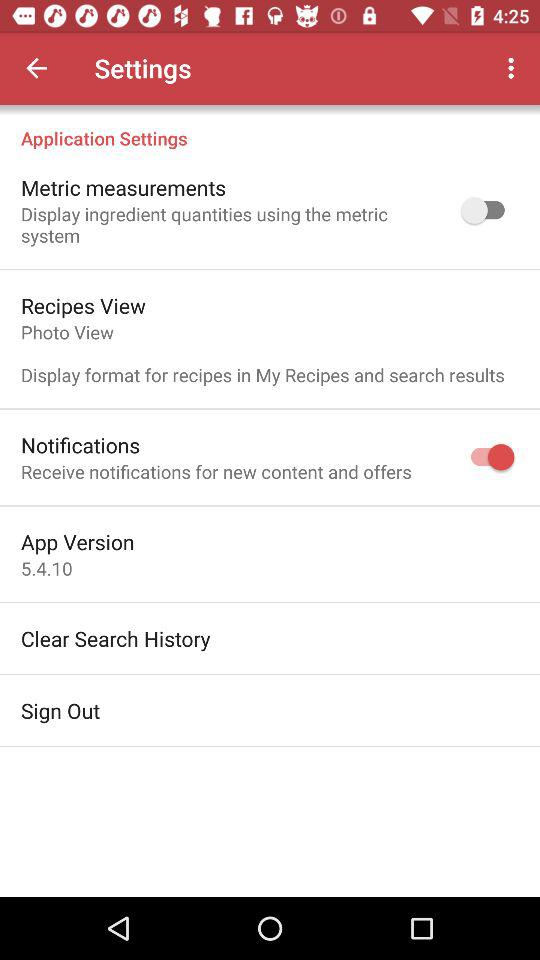How many of the items in the settings menu have a switch?
Answer the question using a single word or phrase. 2 